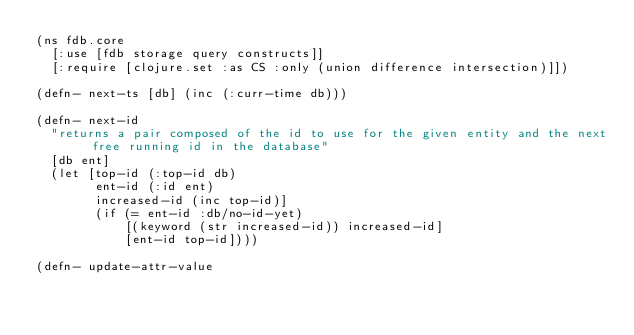<code> <loc_0><loc_0><loc_500><loc_500><_Clojure_>(ns fdb.core
  [:use [fdb storage query constructs]]
  [:require [clojure.set :as CS :only (union difference intersection)]])

(defn- next-ts [db] (inc (:curr-time db)))

(defn- next-id
  "returns a pair composed of the id to use for the given entity and the next free running id in the database"
  [db ent]
  (let [top-id (:top-id db)
        ent-id (:id ent)
        increased-id (inc top-id)]
        (if (= ent-id :db/no-id-yet)
            [(keyword (str increased-id)) increased-id]
            [ent-id top-id])))

(defn- update-attr-value</code> 